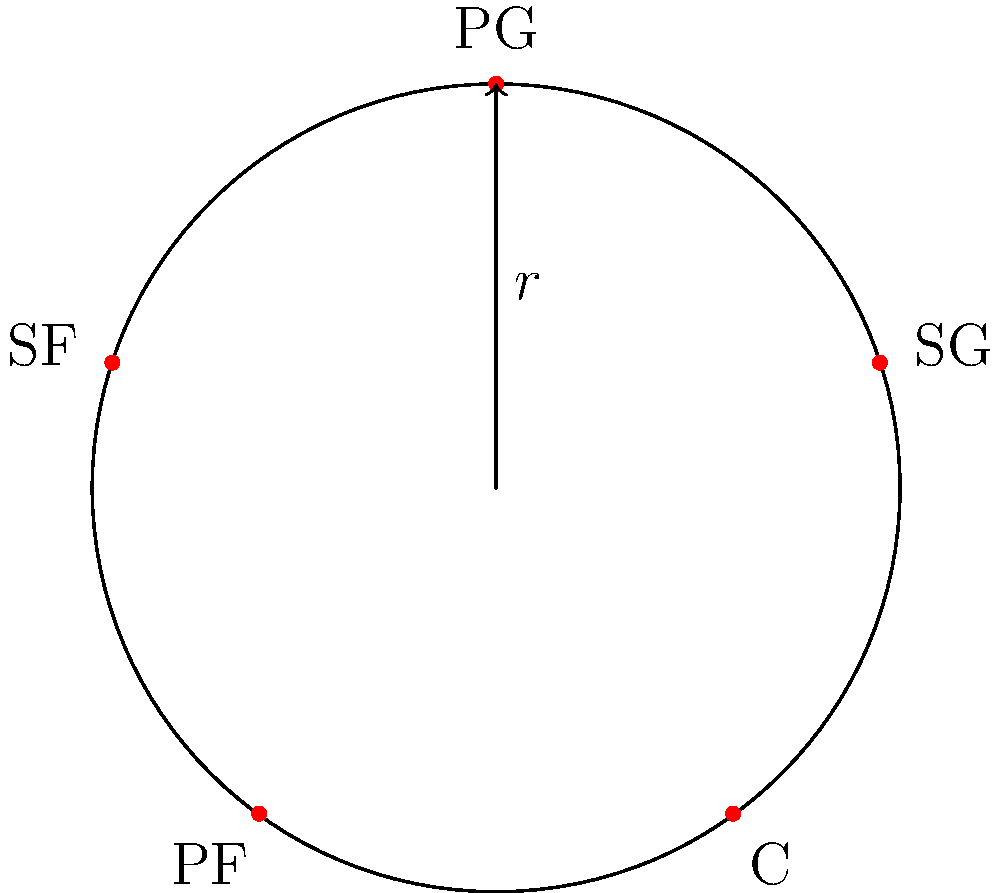In a basketball formation, players are arranged in a cyclic group based on their positions: Point Guard (PG), Shooting Guard (SG), Center (C), Power Forward (PF), and Small Forward (SF). If $r$ represents a clockwise rotation that moves each player to the next position, what is the order of the cyclic group generated by $r$? To determine the order of the cyclic group generated by $r$, we need to follow these steps:

1) First, let's understand what $r$ does:
   $r$: PG → SG → C → PF → SF → PG

2) We need to find how many times we need to apply $r$ to get back to the original position:
   
   $r^1$: PG → SG → C → PF → SF → PG
   $r^2$: PG → C → SF → SG → PF → PG
   $r^3$: PG → PF → SG → SF → C → PG
   $r^4$: PG → SF → PF → C → SG → PG
   $r^5$: PG → PG → PG → PG → PG → PG

3) We see that after applying $r$ five times, we get back to the original position.

4) In group theory, this means that the order of the element $r$ is 5.

5) Since $r$ generates the entire group (it can produce all possible arrangements), the order of the cyclic group is also 5.

Therefore, the cyclic group generated by $r$ has an order of 5, which we denote as $|\langle r \rangle| = 5$ or $|G| = 5$, where $G$ is the group.
Answer: 5 